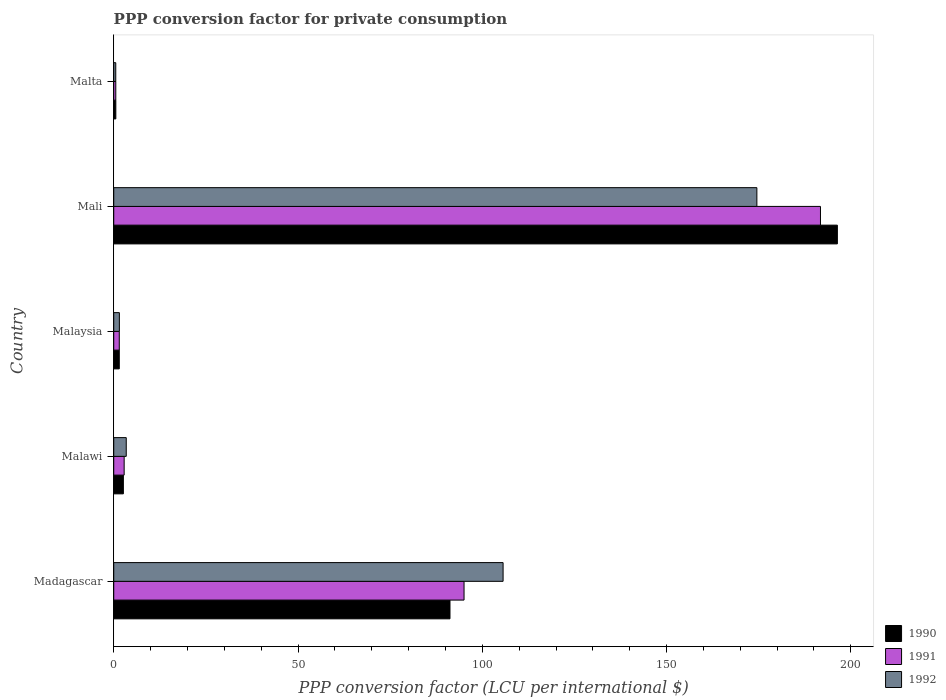How many different coloured bars are there?
Give a very brief answer. 3. Are the number of bars on each tick of the Y-axis equal?
Your response must be concise. Yes. How many bars are there on the 5th tick from the top?
Offer a very short reply. 3. What is the label of the 1st group of bars from the top?
Offer a very short reply. Malta. In how many cases, is the number of bars for a given country not equal to the number of legend labels?
Your response must be concise. 0. What is the PPP conversion factor for private consumption in 1991 in Malaysia?
Keep it short and to the point. 1.5. Across all countries, what is the maximum PPP conversion factor for private consumption in 1992?
Your answer should be very brief. 174.51. Across all countries, what is the minimum PPP conversion factor for private consumption in 1992?
Your answer should be very brief. 0.55. In which country was the PPP conversion factor for private consumption in 1990 maximum?
Ensure brevity in your answer.  Mali. In which country was the PPP conversion factor for private consumption in 1990 minimum?
Provide a succinct answer. Malta. What is the total PPP conversion factor for private consumption in 1991 in the graph?
Your response must be concise. 291.7. What is the difference between the PPP conversion factor for private consumption in 1990 in Malawi and that in Malta?
Your response must be concise. 2.05. What is the difference between the PPP conversion factor for private consumption in 1992 in Malawi and the PPP conversion factor for private consumption in 1991 in Madagascar?
Make the answer very short. -91.66. What is the average PPP conversion factor for private consumption in 1990 per country?
Make the answer very short. 58.45. What is the difference between the PPP conversion factor for private consumption in 1990 and PPP conversion factor for private consumption in 1991 in Malta?
Offer a terse response. 0.01. What is the ratio of the PPP conversion factor for private consumption in 1990 in Malaysia to that in Malta?
Provide a short and direct response. 2.65. Is the difference between the PPP conversion factor for private consumption in 1990 in Madagascar and Malta greater than the difference between the PPP conversion factor for private consumption in 1991 in Madagascar and Malta?
Keep it short and to the point. No. What is the difference between the highest and the second highest PPP conversion factor for private consumption in 1991?
Keep it short and to the point. 96.71. What is the difference between the highest and the lowest PPP conversion factor for private consumption in 1992?
Give a very brief answer. 173.95. In how many countries, is the PPP conversion factor for private consumption in 1990 greater than the average PPP conversion factor for private consumption in 1990 taken over all countries?
Offer a terse response. 2. Is the sum of the PPP conversion factor for private consumption in 1991 in Malaysia and Mali greater than the maximum PPP conversion factor for private consumption in 1990 across all countries?
Offer a terse response. No. What does the 3rd bar from the top in Mali represents?
Offer a very short reply. 1990. Is it the case that in every country, the sum of the PPP conversion factor for private consumption in 1992 and PPP conversion factor for private consumption in 1991 is greater than the PPP conversion factor for private consumption in 1990?
Keep it short and to the point. Yes. How many bars are there?
Provide a succinct answer. 15. How many countries are there in the graph?
Provide a succinct answer. 5. Does the graph contain grids?
Your answer should be compact. No. Where does the legend appear in the graph?
Offer a very short reply. Bottom right. How many legend labels are there?
Provide a succinct answer. 3. How are the legend labels stacked?
Keep it short and to the point. Vertical. What is the title of the graph?
Keep it short and to the point. PPP conversion factor for private consumption. What is the label or title of the X-axis?
Your answer should be very brief. PPP conversion factor (LCU per international $). What is the PPP conversion factor (LCU per international $) in 1990 in Madagascar?
Your response must be concise. 91.24. What is the PPP conversion factor (LCU per international $) in 1991 in Madagascar?
Make the answer very short. 95.05. What is the PPP conversion factor (LCU per international $) of 1992 in Madagascar?
Offer a terse response. 105.64. What is the PPP conversion factor (LCU per international $) in 1990 in Malawi?
Provide a succinct answer. 2.62. What is the PPP conversion factor (LCU per international $) of 1991 in Malawi?
Ensure brevity in your answer.  2.83. What is the PPP conversion factor (LCU per international $) of 1992 in Malawi?
Provide a succinct answer. 3.39. What is the PPP conversion factor (LCU per international $) in 1990 in Malaysia?
Give a very brief answer. 1.5. What is the PPP conversion factor (LCU per international $) in 1991 in Malaysia?
Your response must be concise. 1.5. What is the PPP conversion factor (LCU per international $) of 1992 in Malaysia?
Your answer should be very brief. 1.53. What is the PPP conversion factor (LCU per international $) of 1990 in Mali?
Give a very brief answer. 196.35. What is the PPP conversion factor (LCU per international $) of 1991 in Mali?
Ensure brevity in your answer.  191.76. What is the PPP conversion factor (LCU per international $) in 1992 in Mali?
Keep it short and to the point. 174.51. What is the PPP conversion factor (LCU per international $) in 1990 in Malta?
Your answer should be compact. 0.57. What is the PPP conversion factor (LCU per international $) in 1991 in Malta?
Your answer should be compact. 0.56. What is the PPP conversion factor (LCU per international $) of 1992 in Malta?
Ensure brevity in your answer.  0.55. Across all countries, what is the maximum PPP conversion factor (LCU per international $) in 1990?
Your response must be concise. 196.35. Across all countries, what is the maximum PPP conversion factor (LCU per international $) of 1991?
Keep it short and to the point. 191.76. Across all countries, what is the maximum PPP conversion factor (LCU per international $) in 1992?
Keep it short and to the point. 174.51. Across all countries, what is the minimum PPP conversion factor (LCU per international $) of 1990?
Make the answer very short. 0.57. Across all countries, what is the minimum PPP conversion factor (LCU per international $) in 1991?
Your answer should be compact. 0.56. Across all countries, what is the minimum PPP conversion factor (LCU per international $) of 1992?
Make the answer very short. 0.55. What is the total PPP conversion factor (LCU per international $) of 1990 in the graph?
Provide a succinct answer. 292.27. What is the total PPP conversion factor (LCU per international $) of 1991 in the graph?
Offer a terse response. 291.7. What is the total PPP conversion factor (LCU per international $) of 1992 in the graph?
Give a very brief answer. 285.62. What is the difference between the PPP conversion factor (LCU per international $) of 1990 in Madagascar and that in Malawi?
Provide a short and direct response. 88.62. What is the difference between the PPP conversion factor (LCU per international $) in 1991 in Madagascar and that in Malawi?
Your response must be concise. 92.22. What is the difference between the PPP conversion factor (LCU per international $) in 1992 in Madagascar and that in Malawi?
Provide a succinct answer. 102.25. What is the difference between the PPP conversion factor (LCU per international $) of 1990 in Madagascar and that in Malaysia?
Provide a short and direct response. 89.73. What is the difference between the PPP conversion factor (LCU per international $) of 1991 in Madagascar and that in Malaysia?
Provide a short and direct response. 93.55. What is the difference between the PPP conversion factor (LCU per international $) of 1992 in Madagascar and that in Malaysia?
Provide a short and direct response. 104.11. What is the difference between the PPP conversion factor (LCU per international $) of 1990 in Madagascar and that in Mali?
Offer a very short reply. -105.11. What is the difference between the PPP conversion factor (LCU per international $) of 1991 in Madagascar and that in Mali?
Make the answer very short. -96.71. What is the difference between the PPP conversion factor (LCU per international $) of 1992 in Madagascar and that in Mali?
Offer a terse response. -68.86. What is the difference between the PPP conversion factor (LCU per international $) in 1990 in Madagascar and that in Malta?
Provide a short and direct response. 90.67. What is the difference between the PPP conversion factor (LCU per international $) of 1991 in Madagascar and that in Malta?
Your answer should be compact. 94.49. What is the difference between the PPP conversion factor (LCU per international $) of 1992 in Madagascar and that in Malta?
Make the answer very short. 105.09. What is the difference between the PPP conversion factor (LCU per international $) in 1990 in Malawi and that in Malaysia?
Provide a succinct answer. 1.11. What is the difference between the PPP conversion factor (LCU per international $) of 1991 in Malawi and that in Malaysia?
Keep it short and to the point. 1.32. What is the difference between the PPP conversion factor (LCU per international $) in 1992 in Malawi and that in Malaysia?
Your answer should be very brief. 1.86. What is the difference between the PPP conversion factor (LCU per international $) of 1990 in Malawi and that in Mali?
Give a very brief answer. -193.73. What is the difference between the PPP conversion factor (LCU per international $) in 1991 in Malawi and that in Mali?
Your answer should be compact. -188.94. What is the difference between the PPP conversion factor (LCU per international $) in 1992 in Malawi and that in Mali?
Ensure brevity in your answer.  -171.11. What is the difference between the PPP conversion factor (LCU per international $) in 1990 in Malawi and that in Malta?
Provide a short and direct response. 2.05. What is the difference between the PPP conversion factor (LCU per international $) in 1991 in Malawi and that in Malta?
Your answer should be compact. 2.27. What is the difference between the PPP conversion factor (LCU per international $) of 1992 in Malawi and that in Malta?
Your answer should be very brief. 2.84. What is the difference between the PPP conversion factor (LCU per international $) in 1990 in Malaysia and that in Mali?
Offer a terse response. -194.84. What is the difference between the PPP conversion factor (LCU per international $) of 1991 in Malaysia and that in Mali?
Offer a terse response. -190.26. What is the difference between the PPP conversion factor (LCU per international $) of 1992 in Malaysia and that in Mali?
Keep it short and to the point. -172.98. What is the difference between the PPP conversion factor (LCU per international $) of 1990 in Malaysia and that in Malta?
Give a very brief answer. 0.94. What is the difference between the PPP conversion factor (LCU per international $) in 1991 in Malaysia and that in Malta?
Provide a succinct answer. 0.95. What is the difference between the PPP conversion factor (LCU per international $) in 1990 in Mali and that in Malta?
Your answer should be compact. 195.78. What is the difference between the PPP conversion factor (LCU per international $) of 1991 in Mali and that in Malta?
Make the answer very short. 191.2. What is the difference between the PPP conversion factor (LCU per international $) of 1992 in Mali and that in Malta?
Your response must be concise. 173.95. What is the difference between the PPP conversion factor (LCU per international $) of 1990 in Madagascar and the PPP conversion factor (LCU per international $) of 1991 in Malawi?
Offer a very short reply. 88.41. What is the difference between the PPP conversion factor (LCU per international $) in 1990 in Madagascar and the PPP conversion factor (LCU per international $) in 1992 in Malawi?
Provide a short and direct response. 87.84. What is the difference between the PPP conversion factor (LCU per international $) of 1991 in Madagascar and the PPP conversion factor (LCU per international $) of 1992 in Malawi?
Your answer should be compact. 91.66. What is the difference between the PPP conversion factor (LCU per international $) in 1990 in Madagascar and the PPP conversion factor (LCU per international $) in 1991 in Malaysia?
Give a very brief answer. 89.73. What is the difference between the PPP conversion factor (LCU per international $) of 1990 in Madagascar and the PPP conversion factor (LCU per international $) of 1992 in Malaysia?
Provide a succinct answer. 89.71. What is the difference between the PPP conversion factor (LCU per international $) in 1991 in Madagascar and the PPP conversion factor (LCU per international $) in 1992 in Malaysia?
Keep it short and to the point. 93.52. What is the difference between the PPP conversion factor (LCU per international $) in 1990 in Madagascar and the PPP conversion factor (LCU per international $) in 1991 in Mali?
Provide a short and direct response. -100.53. What is the difference between the PPP conversion factor (LCU per international $) of 1990 in Madagascar and the PPP conversion factor (LCU per international $) of 1992 in Mali?
Provide a short and direct response. -83.27. What is the difference between the PPP conversion factor (LCU per international $) in 1991 in Madagascar and the PPP conversion factor (LCU per international $) in 1992 in Mali?
Your answer should be very brief. -79.46. What is the difference between the PPP conversion factor (LCU per international $) of 1990 in Madagascar and the PPP conversion factor (LCU per international $) of 1991 in Malta?
Provide a succinct answer. 90.68. What is the difference between the PPP conversion factor (LCU per international $) of 1990 in Madagascar and the PPP conversion factor (LCU per international $) of 1992 in Malta?
Offer a terse response. 90.69. What is the difference between the PPP conversion factor (LCU per international $) of 1991 in Madagascar and the PPP conversion factor (LCU per international $) of 1992 in Malta?
Offer a very short reply. 94.5. What is the difference between the PPP conversion factor (LCU per international $) of 1990 in Malawi and the PPP conversion factor (LCU per international $) of 1992 in Malaysia?
Make the answer very short. 1.09. What is the difference between the PPP conversion factor (LCU per international $) in 1991 in Malawi and the PPP conversion factor (LCU per international $) in 1992 in Malaysia?
Your answer should be very brief. 1.3. What is the difference between the PPP conversion factor (LCU per international $) of 1990 in Malawi and the PPP conversion factor (LCU per international $) of 1991 in Mali?
Provide a short and direct response. -189.15. What is the difference between the PPP conversion factor (LCU per international $) in 1990 in Malawi and the PPP conversion factor (LCU per international $) in 1992 in Mali?
Your answer should be very brief. -171.89. What is the difference between the PPP conversion factor (LCU per international $) in 1991 in Malawi and the PPP conversion factor (LCU per international $) in 1992 in Mali?
Your answer should be compact. -171.68. What is the difference between the PPP conversion factor (LCU per international $) of 1990 in Malawi and the PPP conversion factor (LCU per international $) of 1991 in Malta?
Keep it short and to the point. 2.06. What is the difference between the PPP conversion factor (LCU per international $) in 1990 in Malawi and the PPP conversion factor (LCU per international $) in 1992 in Malta?
Give a very brief answer. 2.06. What is the difference between the PPP conversion factor (LCU per international $) of 1991 in Malawi and the PPP conversion factor (LCU per international $) of 1992 in Malta?
Offer a terse response. 2.27. What is the difference between the PPP conversion factor (LCU per international $) of 1990 in Malaysia and the PPP conversion factor (LCU per international $) of 1991 in Mali?
Give a very brief answer. -190.26. What is the difference between the PPP conversion factor (LCU per international $) of 1990 in Malaysia and the PPP conversion factor (LCU per international $) of 1992 in Mali?
Your answer should be very brief. -173. What is the difference between the PPP conversion factor (LCU per international $) in 1991 in Malaysia and the PPP conversion factor (LCU per international $) in 1992 in Mali?
Your response must be concise. -173. What is the difference between the PPP conversion factor (LCU per international $) of 1990 in Malaysia and the PPP conversion factor (LCU per international $) of 1991 in Malta?
Your response must be concise. 0.94. What is the difference between the PPP conversion factor (LCU per international $) of 1990 in Malaysia and the PPP conversion factor (LCU per international $) of 1992 in Malta?
Make the answer very short. 0.95. What is the difference between the PPP conversion factor (LCU per international $) in 1991 in Malaysia and the PPP conversion factor (LCU per international $) in 1992 in Malta?
Make the answer very short. 0.95. What is the difference between the PPP conversion factor (LCU per international $) in 1990 in Mali and the PPP conversion factor (LCU per international $) in 1991 in Malta?
Offer a very short reply. 195.79. What is the difference between the PPP conversion factor (LCU per international $) in 1990 in Mali and the PPP conversion factor (LCU per international $) in 1992 in Malta?
Provide a succinct answer. 195.8. What is the difference between the PPP conversion factor (LCU per international $) of 1991 in Mali and the PPP conversion factor (LCU per international $) of 1992 in Malta?
Provide a short and direct response. 191.21. What is the average PPP conversion factor (LCU per international $) of 1990 per country?
Provide a short and direct response. 58.45. What is the average PPP conversion factor (LCU per international $) of 1991 per country?
Provide a succinct answer. 58.34. What is the average PPP conversion factor (LCU per international $) in 1992 per country?
Your answer should be very brief. 57.12. What is the difference between the PPP conversion factor (LCU per international $) in 1990 and PPP conversion factor (LCU per international $) in 1991 in Madagascar?
Ensure brevity in your answer.  -3.81. What is the difference between the PPP conversion factor (LCU per international $) in 1990 and PPP conversion factor (LCU per international $) in 1992 in Madagascar?
Offer a very short reply. -14.41. What is the difference between the PPP conversion factor (LCU per international $) of 1991 and PPP conversion factor (LCU per international $) of 1992 in Madagascar?
Keep it short and to the point. -10.59. What is the difference between the PPP conversion factor (LCU per international $) in 1990 and PPP conversion factor (LCU per international $) in 1991 in Malawi?
Give a very brief answer. -0.21. What is the difference between the PPP conversion factor (LCU per international $) in 1990 and PPP conversion factor (LCU per international $) in 1992 in Malawi?
Make the answer very short. -0.78. What is the difference between the PPP conversion factor (LCU per international $) in 1991 and PPP conversion factor (LCU per international $) in 1992 in Malawi?
Keep it short and to the point. -0.57. What is the difference between the PPP conversion factor (LCU per international $) of 1990 and PPP conversion factor (LCU per international $) of 1991 in Malaysia?
Your answer should be compact. -0. What is the difference between the PPP conversion factor (LCU per international $) of 1990 and PPP conversion factor (LCU per international $) of 1992 in Malaysia?
Your response must be concise. -0.03. What is the difference between the PPP conversion factor (LCU per international $) in 1991 and PPP conversion factor (LCU per international $) in 1992 in Malaysia?
Your response must be concise. -0.03. What is the difference between the PPP conversion factor (LCU per international $) in 1990 and PPP conversion factor (LCU per international $) in 1991 in Mali?
Offer a very short reply. 4.59. What is the difference between the PPP conversion factor (LCU per international $) of 1990 and PPP conversion factor (LCU per international $) of 1992 in Mali?
Offer a terse response. 21.84. What is the difference between the PPP conversion factor (LCU per international $) of 1991 and PPP conversion factor (LCU per international $) of 1992 in Mali?
Make the answer very short. 17.26. What is the difference between the PPP conversion factor (LCU per international $) in 1990 and PPP conversion factor (LCU per international $) in 1991 in Malta?
Your answer should be compact. 0.01. What is the difference between the PPP conversion factor (LCU per international $) of 1990 and PPP conversion factor (LCU per international $) of 1992 in Malta?
Keep it short and to the point. 0.02. What is the difference between the PPP conversion factor (LCU per international $) in 1991 and PPP conversion factor (LCU per international $) in 1992 in Malta?
Your answer should be compact. 0.01. What is the ratio of the PPP conversion factor (LCU per international $) of 1990 in Madagascar to that in Malawi?
Provide a succinct answer. 34.89. What is the ratio of the PPP conversion factor (LCU per international $) in 1991 in Madagascar to that in Malawi?
Provide a succinct answer. 33.64. What is the ratio of the PPP conversion factor (LCU per international $) of 1992 in Madagascar to that in Malawi?
Offer a very short reply. 31.13. What is the ratio of the PPP conversion factor (LCU per international $) in 1990 in Madagascar to that in Malaysia?
Keep it short and to the point. 60.74. What is the ratio of the PPP conversion factor (LCU per international $) in 1991 in Madagascar to that in Malaysia?
Your answer should be very brief. 63.2. What is the ratio of the PPP conversion factor (LCU per international $) in 1992 in Madagascar to that in Malaysia?
Your answer should be compact. 69.08. What is the ratio of the PPP conversion factor (LCU per international $) in 1990 in Madagascar to that in Mali?
Keep it short and to the point. 0.46. What is the ratio of the PPP conversion factor (LCU per international $) in 1991 in Madagascar to that in Mali?
Your response must be concise. 0.5. What is the ratio of the PPP conversion factor (LCU per international $) of 1992 in Madagascar to that in Mali?
Provide a short and direct response. 0.61. What is the ratio of the PPP conversion factor (LCU per international $) in 1990 in Madagascar to that in Malta?
Keep it short and to the point. 160.88. What is the ratio of the PPP conversion factor (LCU per international $) of 1991 in Madagascar to that in Malta?
Provide a short and direct response. 170.37. What is the ratio of the PPP conversion factor (LCU per international $) of 1992 in Madagascar to that in Malta?
Your response must be concise. 191.96. What is the ratio of the PPP conversion factor (LCU per international $) of 1990 in Malawi to that in Malaysia?
Give a very brief answer. 1.74. What is the ratio of the PPP conversion factor (LCU per international $) in 1991 in Malawi to that in Malaysia?
Offer a very short reply. 1.88. What is the ratio of the PPP conversion factor (LCU per international $) in 1992 in Malawi to that in Malaysia?
Provide a succinct answer. 2.22. What is the ratio of the PPP conversion factor (LCU per international $) of 1990 in Malawi to that in Mali?
Keep it short and to the point. 0.01. What is the ratio of the PPP conversion factor (LCU per international $) in 1991 in Malawi to that in Mali?
Keep it short and to the point. 0.01. What is the ratio of the PPP conversion factor (LCU per international $) in 1992 in Malawi to that in Mali?
Your response must be concise. 0.02. What is the ratio of the PPP conversion factor (LCU per international $) in 1990 in Malawi to that in Malta?
Your answer should be very brief. 4.61. What is the ratio of the PPP conversion factor (LCU per international $) in 1991 in Malawi to that in Malta?
Provide a short and direct response. 5.06. What is the ratio of the PPP conversion factor (LCU per international $) of 1992 in Malawi to that in Malta?
Provide a short and direct response. 6.17. What is the ratio of the PPP conversion factor (LCU per international $) of 1990 in Malaysia to that in Mali?
Keep it short and to the point. 0.01. What is the ratio of the PPP conversion factor (LCU per international $) of 1991 in Malaysia to that in Mali?
Provide a short and direct response. 0.01. What is the ratio of the PPP conversion factor (LCU per international $) in 1992 in Malaysia to that in Mali?
Your answer should be compact. 0.01. What is the ratio of the PPP conversion factor (LCU per international $) in 1990 in Malaysia to that in Malta?
Ensure brevity in your answer.  2.65. What is the ratio of the PPP conversion factor (LCU per international $) in 1991 in Malaysia to that in Malta?
Provide a short and direct response. 2.7. What is the ratio of the PPP conversion factor (LCU per international $) in 1992 in Malaysia to that in Malta?
Offer a terse response. 2.78. What is the ratio of the PPP conversion factor (LCU per international $) of 1990 in Mali to that in Malta?
Keep it short and to the point. 346.22. What is the ratio of the PPP conversion factor (LCU per international $) of 1991 in Mali to that in Malta?
Offer a very short reply. 343.72. What is the ratio of the PPP conversion factor (LCU per international $) of 1992 in Mali to that in Malta?
Ensure brevity in your answer.  317.08. What is the difference between the highest and the second highest PPP conversion factor (LCU per international $) in 1990?
Offer a terse response. 105.11. What is the difference between the highest and the second highest PPP conversion factor (LCU per international $) of 1991?
Make the answer very short. 96.71. What is the difference between the highest and the second highest PPP conversion factor (LCU per international $) in 1992?
Provide a short and direct response. 68.86. What is the difference between the highest and the lowest PPP conversion factor (LCU per international $) in 1990?
Make the answer very short. 195.78. What is the difference between the highest and the lowest PPP conversion factor (LCU per international $) in 1991?
Your answer should be compact. 191.2. What is the difference between the highest and the lowest PPP conversion factor (LCU per international $) of 1992?
Offer a very short reply. 173.95. 